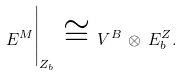Convert formula to latex. <formula><loc_0><loc_0><loc_500><loc_500>E ^ { M } \Big | _ { Z _ { b } } \, \cong \, V ^ { B } \, \otimes \, E ^ { Z } _ { b } .</formula> 